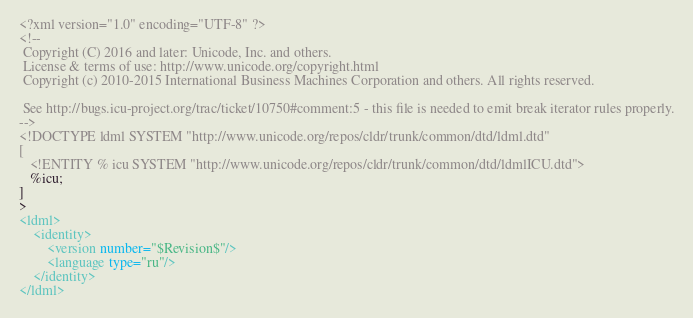<code> <loc_0><loc_0><loc_500><loc_500><_XML_><?xml version="1.0" encoding="UTF-8" ?>
<!--
 Copyright (C) 2016 and later: Unicode, Inc. and others.
 License & terms of use: http://www.unicode.org/copyright.html
 Copyright (c) 2010-2015 International Business Machines Corporation and others. All rights reserved.

 See http://bugs.icu-project.org/trac/ticket/10750#comment:5 - this file is needed to emit break iterator rules properly.
-->
<!DOCTYPE ldml SYSTEM "http://www.unicode.org/repos/cldr/trunk/common/dtd/ldml.dtd"
[
   <!ENTITY % icu SYSTEM "http://www.unicode.org/repos/cldr/trunk/common/dtd/ldmlICU.dtd">
   %icu;
]
>
<ldml>
    <identity>
        <version number="$Revision$"/>
        <language type="ru"/>
    </identity>
</ldml>

</code> 